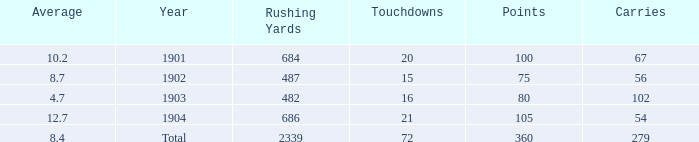How many carries have an average under 8.7 and touchdowns of 72? 1.0. 